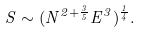Convert formula to latex. <formula><loc_0><loc_0><loc_500><loc_500>S \sim ( N ^ { 2 + \frac { 3 } { 5 } } E ^ { 3 } ) ^ { \frac { 1 } { 4 } } .</formula> 